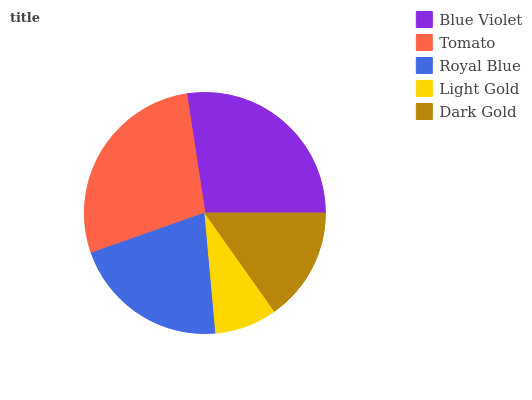Is Light Gold the minimum?
Answer yes or no. Yes. Is Tomato the maximum?
Answer yes or no. Yes. Is Royal Blue the minimum?
Answer yes or no. No. Is Royal Blue the maximum?
Answer yes or no. No. Is Tomato greater than Royal Blue?
Answer yes or no. Yes. Is Royal Blue less than Tomato?
Answer yes or no. Yes. Is Royal Blue greater than Tomato?
Answer yes or no. No. Is Tomato less than Royal Blue?
Answer yes or no. No. Is Royal Blue the high median?
Answer yes or no. Yes. Is Royal Blue the low median?
Answer yes or no. Yes. Is Tomato the high median?
Answer yes or no. No. Is Blue Violet the low median?
Answer yes or no. No. 